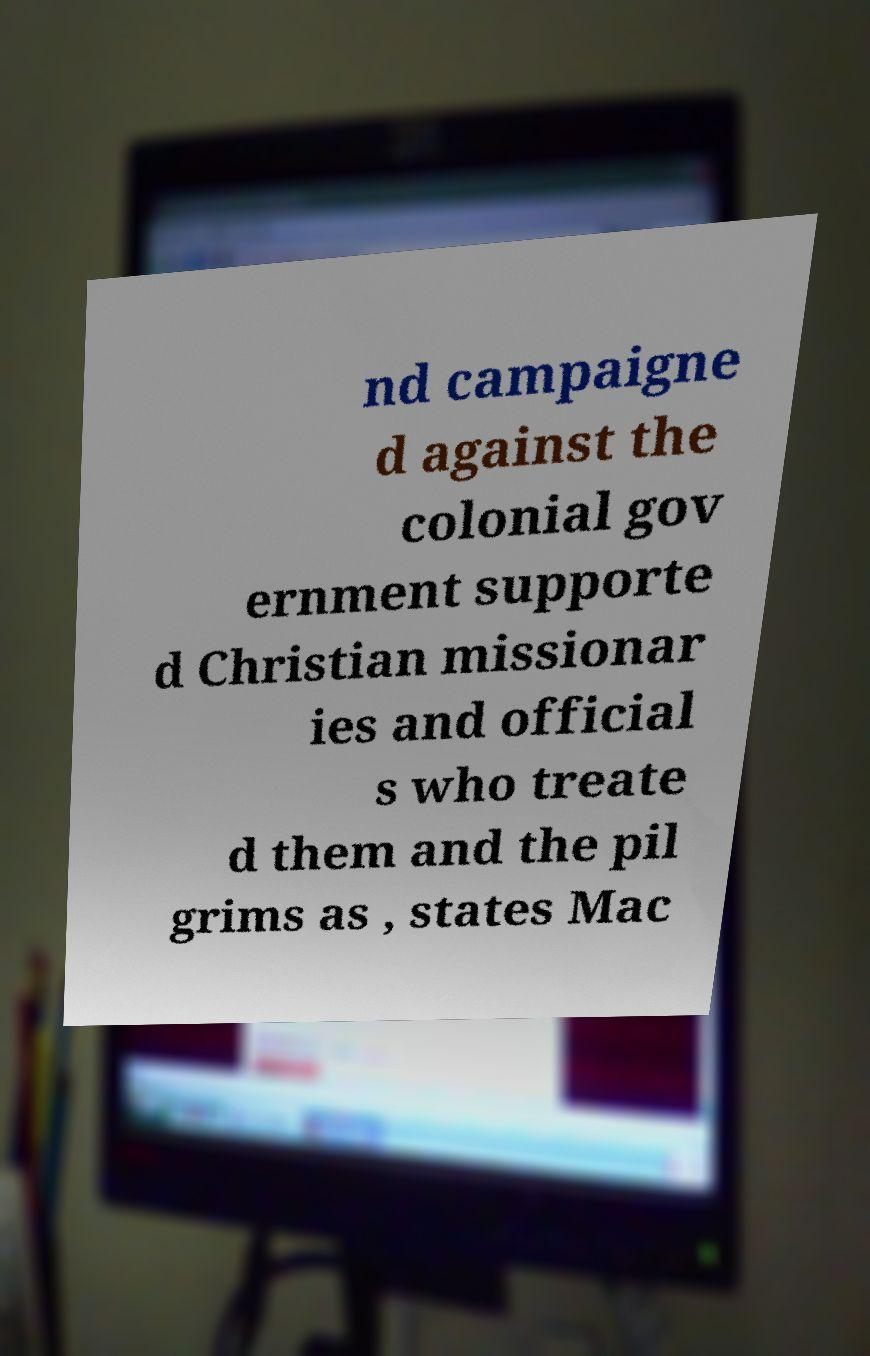There's text embedded in this image that I need extracted. Can you transcribe it verbatim? nd campaigne d against the colonial gov ernment supporte d Christian missionar ies and official s who treate d them and the pil grims as , states Mac 